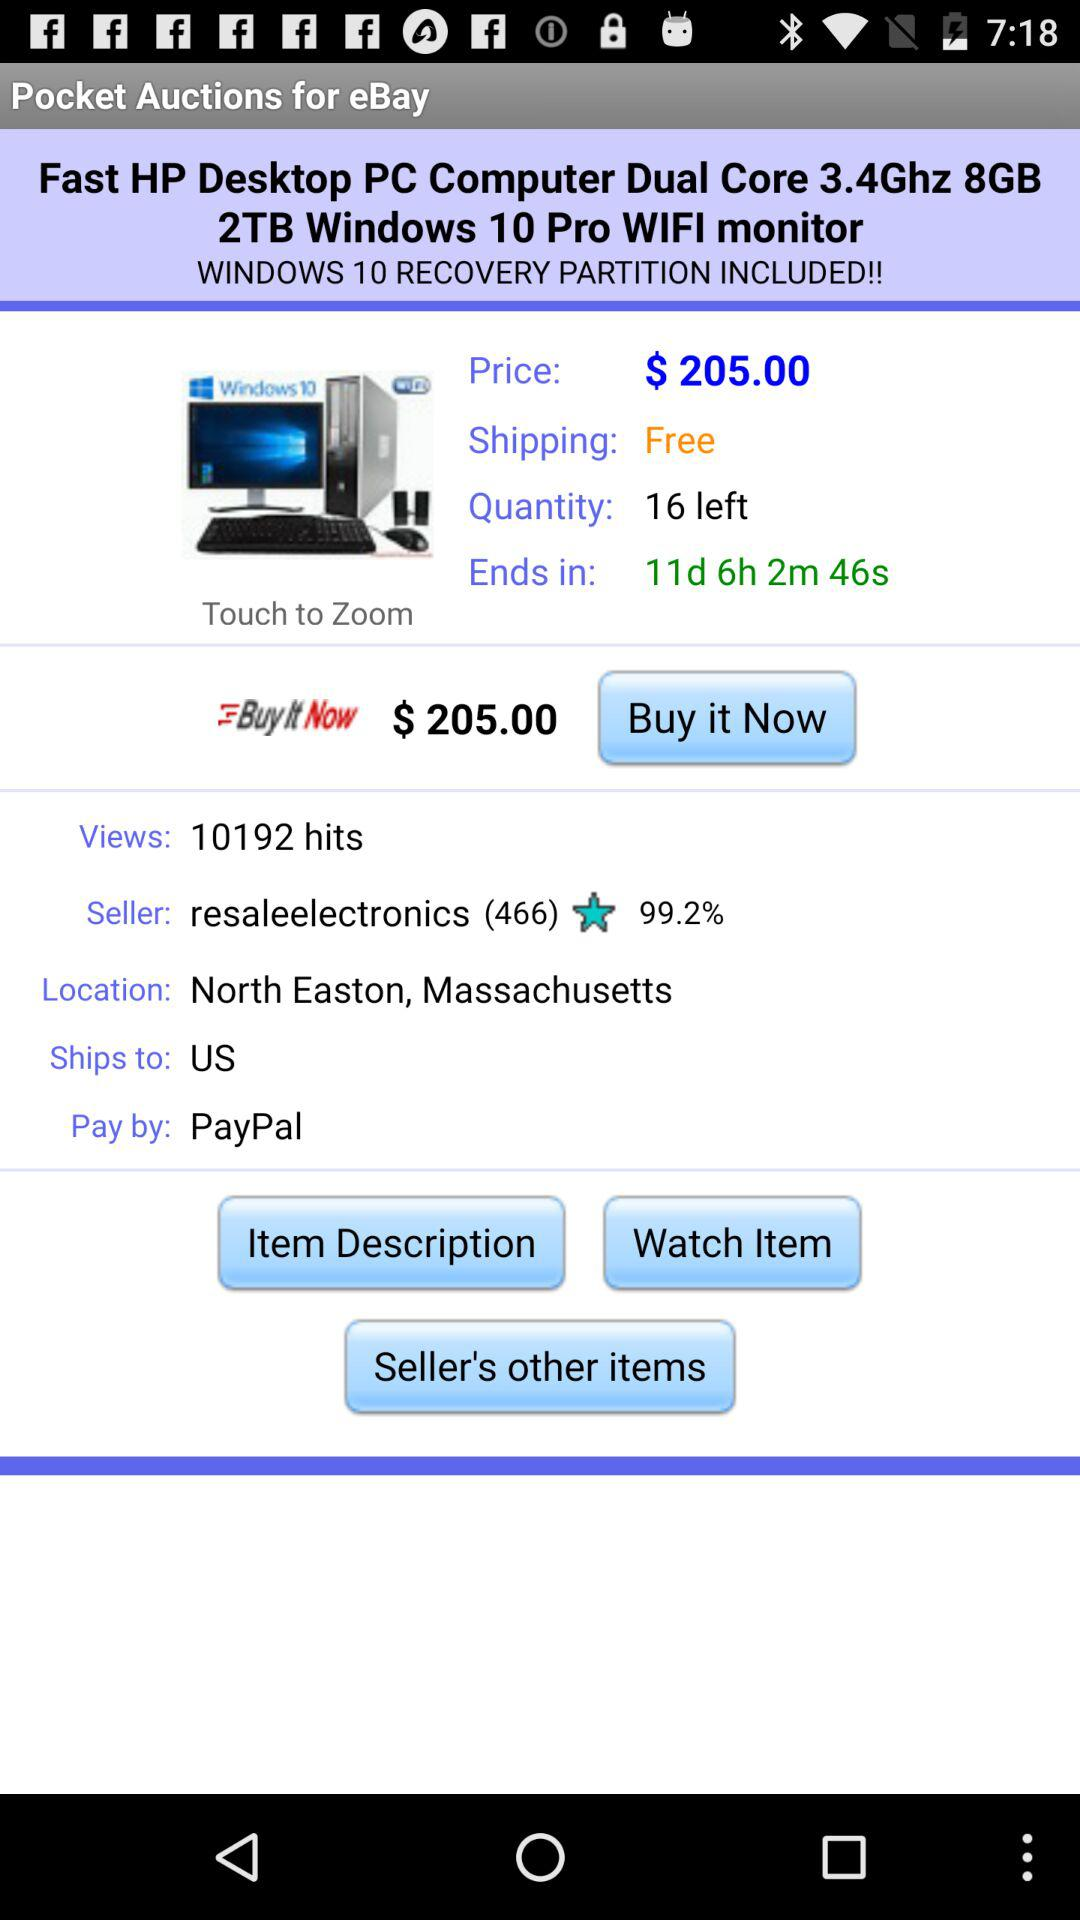What is the total price for 3 of these items?
Answer the question using a single word or phrase. $615.00 